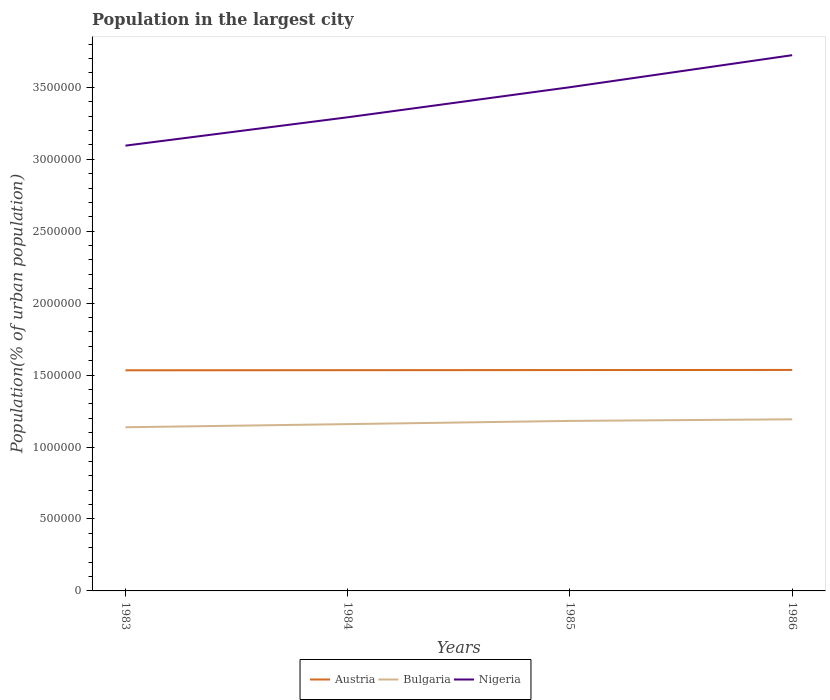Is the number of lines equal to the number of legend labels?
Your response must be concise. Yes. Across all years, what is the maximum population in the largest city in Bulgaria?
Keep it short and to the point. 1.14e+06. What is the total population in the largest city in Austria in the graph?
Offer a very short reply. -850. What is the difference between the highest and the second highest population in the largest city in Bulgaria?
Offer a terse response. 5.51e+04. What is the difference between the highest and the lowest population in the largest city in Austria?
Your answer should be compact. 2. Is the population in the largest city in Austria strictly greater than the population in the largest city in Bulgaria over the years?
Make the answer very short. No. How many years are there in the graph?
Make the answer very short. 4. What is the difference between two consecutive major ticks on the Y-axis?
Give a very brief answer. 5.00e+05. Are the values on the major ticks of Y-axis written in scientific E-notation?
Your answer should be very brief. No. Where does the legend appear in the graph?
Offer a very short reply. Bottom center. How many legend labels are there?
Your answer should be compact. 3. How are the legend labels stacked?
Ensure brevity in your answer.  Horizontal. What is the title of the graph?
Offer a terse response. Population in the largest city. What is the label or title of the X-axis?
Ensure brevity in your answer.  Years. What is the label or title of the Y-axis?
Give a very brief answer. Population(% of urban population). What is the Population(% of urban population) in Austria in 1983?
Offer a terse response. 1.53e+06. What is the Population(% of urban population) of Bulgaria in 1983?
Make the answer very short. 1.14e+06. What is the Population(% of urban population) of Nigeria in 1983?
Your answer should be compact. 3.09e+06. What is the Population(% of urban population) of Austria in 1984?
Your answer should be very brief. 1.53e+06. What is the Population(% of urban population) of Bulgaria in 1984?
Offer a very short reply. 1.16e+06. What is the Population(% of urban population) in Nigeria in 1984?
Give a very brief answer. 3.29e+06. What is the Population(% of urban population) in Austria in 1985?
Your answer should be very brief. 1.53e+06. What is the Population(% of urban population) of Bulgaria in 1985?
Offer a very short reply. 1.18e+06. What is the Population(% of urban population) of Nigeria in 1985?
Offer a very short reply. 3.50e+06. What is the Population(% of urban population) of Austria in 1986?
Provide a succinct answer. 1.54e+06. What is the Population(% of urban population) in Bulgaria in 1986?
Ensure brevity in your answer.  1.19e+06. What is the Population(% of urban population) of Nigeria in 1986?
Give a very brief answer. 3.72e+06. Across all years, what is the maximum Population(% of urban population) in Austria?
Your response must be concise. 1.54e+06. Across all years, what is the maximum Population(% of urban population) in Bulgaria?
Ensure brevity in your answer.  1.19e+06. Across all years, what is the maximum Population(% of urban population) in Nigeria?
Provide a succinct answer. 3.72e+06. Across all years, what is the minimum Population(% of urban population) of Austria?
Your response must be concise. 1.53e+06. Across all years, what is the minimum Population(% of urban population) in Bulgaria?
Keep it short and to the point. 1.14e+06. Across all years, what is the minimum Population(% of urban population) in Nigeria?
Offer a very short reply. 3.09e+06. What is the total Population(% of urban population) in Austria in the graph?
Your answer should be very brief. 6.14e+06. What is the total Population(% of urban population) in Bulgaria in the graph?
Provide a succinct answer. 4.67e+06. What is the total Population(% of urban population) in Nigeria in the graph?
Make the answer very short. 1.36e+07. What is the difference between the Population(% of urban population) in Austria in 1983 and that in 1984?
Keep it short and to the point. -850. What is the difference between the Population(% of urban population) of Bulgaria in 1983 and that in 1984?
Provide a succinct answer. -2.19e+04. What is the difference between the Population(% of urban population) in Nigeria in 1983 and that in 1984?
Your response must be concise. -1.97e+05. What is the difference between the Population(% of urban population) of Austria in 1983 and that in 1985?
Ensure brevity in your answer.  -1698. What is the difference between the Population(% of urban population) in Bulgaria in 1983 and that in 1985?
Provide a succinct answer. -4.41e+04. What is the difference between the Population(% of urban population) in Nigeria in 1983 and that in 1985?
Provide a succinct answer. -4.06e+05. What is the difference between the Population(% of urban population) in Austria in 1983 and that in 1986?
Offer a terse response. -2547. What is the difference between the Population(% of urban population) in Bulgaria in 1983 and that in 1986?
Ensure brevity in your answer.  -5.51e+04. What is the difference between the Population(% of urban population) of Nigeria in 1983 and that in 1986?
Keep it short and to the point. -6.29e+05. What is the difference between the Population(% of urban population) of Austria in 1984 and that in 1985?
Make the answer very short. -848. What is the difference between the Population(% of urban population) in Bulgaria in 1984 and that in 1985?
Keep it short and to the point. -2.22e+04. What is the difference between the Population(% of urban population) of Nigeria in 1984 and that in 1985?
Offer a terse response. -2.09e+05. What is the difference between the Population(% of urban population) of Austria in 1984 and that in 1986?
Your answer should be compact. -1697. What is the difference between the Population(% of urban population) of Bulgaria in 1984 and that in 1986?
Give a very brief answer. -3.33e+04. What is the difference between the Population(% of urban population) in Nigeria in 1984 and that in 1986?
Keep it short and to the point. -4.32e+05. What is the difference between the Population(% of urban population) in Austria in 1985 and that in 1986?
Make the answer very short. -849. What is the difference between the Population(% of urban population) in Bulgaria in 1985 and that in 1986?
Make the answer very short. -1.11e+04. What is the difference between the Population(% of urban population) of Nigeria in 1985 and that in 1986?
Ensure brevity in your answer.  -2.23e+05. What is the difference between the Population(% of urban population) of Austria in 1983 and the Population(% of urban population) of Bulgaria in 1984?
Your answer should be compact. 3.74e+05. What is the difference between the Population(% of urban population) of Austria in 1983 and the Population(% of urban population) of Nigeria in 1984?
Your response must be concise. -1.76e+06. What is the difference between the Population(% of urban population) in Bulgaria in 1983 and the Population(% of urban population) in Nigeria in 1984?
Provide a succinct answer. -2.15e+06. What is the difference between the Population(% of urban population) of Austria in 1983 and the Population(% of urban population) of Bulgaria in 1985?
Your response must be concise. 3.52e+05. What is the difference between the Population(% of urban population) of Austria in 1983 and the Population(% of urban population) of Nigeria in 1985?
Your answer should be very brief. -1.97e+06. What is the difference between the Population(% of urban population) in Bulgaria in 1983 and the Population(% of urban population) in Nigeria in 1985?
Make the answer very short. -2.36e+06. What is the difference between the Population(% of urban population) in Austria in 1983 and the Population(% of urban population) in Bulgaria in 1986?
Offer a very short reply. 3.41e+05. What is the difference between the Population(% of urban population) in Austria in 1983 and the Population(% of urban population) in Nigeria in 1986?
Your response must be concise. -2.19e+06. What is the difference between the Population(% of urban population) in Bulgaria in 1983 and the Population(% of urban population) in Nigeria in 1986?
Make the answer very short. -2.59e+06. What is the difference between the Population(% of urban population) of Austria in 1984 and the Population(% of urban population) of Bulgaria in 1985?
Your answer should be compact. 3.53e+05. What is the difference between the Population(% of urban population) of Austria in 1984 and the Population(% of urban population) of Nigeria in 1985?
Ensure brevity in your answer.  -1.97e+06. What is the difference between the Population(% of urban population) in Bulgaria in 1984 and the Population(% of urban population) in Nigeria in 1985?
Keep it short and to the point. -2.34e+06. What is the difference between the Population(% of urban population) of Austria in 1984 and the Population(% of urban population) of Bulgaria in 1986?
Your answer should be compact. 3.41e+05. What is the difference between the Population(% of urban population) in Austria in 1984 and the Population(% of urban population) in Nigeria in 1986?
Your response must be concise. -2.19e+06. What is the difference between the Population(% of urban population) in Bulgaria in 1984 and the Population(% of urban population) in Nigeria in 1986?
Give a very brief answer. -2.56e+06. What is the difference between the Population(% of urban population) in Austria in 1985 and the Population(% of urban population) in Bulgaria in 1986?
Provide a succinct answer. 3.42e+05. What is the difference between the Population(% of urban population) of Austria in 1985 and the Population(% of urban population) of Nigeria in 1986?
Provide a short and direct response. -2.19e+06. What is the difference between the Population(% of urban population) in Bulgaria in 1985 and the Population(% of urban population) in Nigeria in 1986?
Provide a short and direct response. -2.54e+06. What is the average Population(% of urban population) in Austria per year?
Ensure brevity in your answer.  1.53e+06. What is the average Population(% of urban population) of Bulgaria per year?
Your answer should be compact. 1.17e+06. What is the average Population(% of urban population) in Nigeria per year?
Give a very brief answer. 3.40e+06. In the year 1983, what is the difference between the Population(% of urban population) in Austria and Population(% of urban population) in Bulgaria?
Give a very brief answer. 3.96e+05. In the year 1983, what is the difference between the Population(% of urban population) of Austria and Population(% of urban population) of Nigeria?
Offer a terse response. -1.56e+06. In the year 1983, what is the difference between the Population(% of urban population) of Bulgaria and Population(% of urban population) of Nigeria?
Offer a very short reply. -1.96e+06. In the year 1984, what is the difference between the Population(% of urban population) in Austria and Population(% of urban population) in Bulgaria?
Offer a terse response. 3.75e+05. In the year 1984, what is the difference between the Population(% of urban population) of Austria and Population(% of urban population) of Nigeria?
Make the answer very short. -1.76e+06. In the year 1984, what is the difference between the Population(% of urban population) of Bulgaria and Population(% of urban population) of Nigeria?
Your answer should be very brief. -2.13e+06. In the year 1985, what is the difference between the Population(% of urban population) of Austria and Population(% of urban population) of Bulgaria?
Provide a short and direct response. 3.53e+05. In the year 1985, what is the difference between the Population(% of urban population) in Austria and Population(% of urban population) in Nigeria?
Make the answer very short. -1.97e+06. In the year 1985, what is the difference between the Population(% of urban population) of Bulgaria and Population(% of urban population) of Nigeria?
Your answer should be compact. -2.32e+06. In the year 1986, what is the difference between the Population(% of urban population) of Austria and Population(% of urban population) of Bulgaria?
Keep it short and to the point. 3.43e+05. In the year 1986, what is the difference between the Population(% of urban population) of Austria and Population(% of urban population) of Nigeria?
Make the answer very short. -2.19e+06. In the year 1986, what is the difference between the Population(% of urban population) in Bulgaria and Population(% of urban population) in Nigeria?
Your answer should be compact. -2.53e+06. What is the ratio of the Population(% of urban population) of Austria in 1983 to that in 1984?
Keep it short and to the point. 1. What is the ratio of the Population(% of urban population) of Bulgaria in 1983 to that in 1984?
Your answer should be compact. 0.98. What is the ratio of the Population(% of urban population) in Nigeria in 1983 to that in 1984?
Provide a short and direct response. 0.94. What is the ratio of the Population(% of urban population) of Austria in 1983 to that in 1985?
Your answer should be very brief. 1. What is the ratio of the Population(% of urban population) of Bulgaria in 1983 to that in 1985?
Your response must be concise. 0.96. What is the ratio of the Population(% of urban population) in Nigeria in 1983 to that in 1985?
Offer a very short reply. 0.88. What is the ratio of the Population(% of urban population) in Austria in 1983 to that in 1986?
Provide a short and direct response. 1. What is the ratio of the Population(% of urban population) in Bulgaria in 1983 to that in 1986?
Give a very brief answer. 0.95. What is the ratio of the Population(% of urban population) in Nigeria in 1983 to that in 1986?
Your answer should be compact. 0.83. What is the ratio of the Population(% of urban population) of Bulgaria in 1984 to that in 1985?
Your answer should be very brief. 0.98. What is the ratio of the Population(% of urban population) in Nigeria in 1984 to that in 1985?
Keep it short and to the point. 0.94. What is the ratio of the Population(% of urban population) in Austria in 1984 to that in 1986?
Give a very brief answer. 1. What is the ratio of the Population(% of urban population) of Bulgaria in 1984 to that in 1986?
Offer a very short reply. 0.97. What is the ratio of the Population(% of urban population) in Nigeria in 1984 to that in 1986?
Give a very brief answer. 0.88. What is the ratio of the Population(% of urban population) of Nigeria in 1985 to that in 1986?
Your answer should be compact. 0.94. What is the difference between the highest and the second highest Population(% of urban population) of Austria?
Make the answer very short. 849. What is the difference between the highest and the second highest Population(% of urban population) of Bulgaria?
Your answer should be very brief. 1.11e+04. What is the difference between the highest and the second highest Population(% of urban population) of Nigeria?
Ensure brevity in your answer.  2.23e+05. What is the difference between the highest and the lowest Population(% of urban population) in Austria?
Give a very brief answer. 2547. What is the difference between the highest and the lowest Population(% of urban population) in Bulgaria?
Give a very brief answer. 5.51e+04. What is the difference between the highest and the lowest Population(% of urban population) of Nigeria?
Your response must be concise. 6.29e+05. 